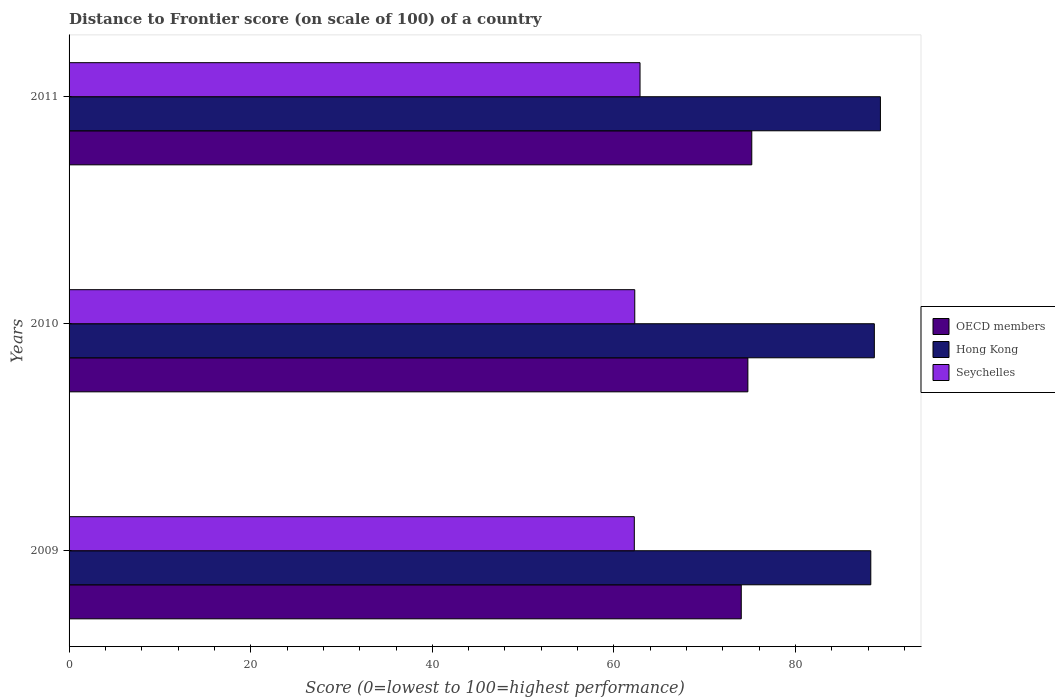How many different coloured bars are there?
Give a very brief answer. 3. How many bars are there on the 3rd tick from the top?
Give a very brief answer. 3. How many bars are there on the 2nd tick from the bottom?
Your answer should be compact. 3. What is the label of the 2nd group of bars from the top?
Give a very brief answer. 2010. In how many cases, is the number of bars for a given year not equal to the number of legend labels?
Give a very brief answer. 0. What is the distance to frontier score of in Seychelles in 2009?
Make the answer very short. 62.24. Across all years, what is the maximum distance to frontier score of in OECD members?
Make the answer very short. 75.18. Across all years, what is the minimum distance to frontier score of in Hong Kong?
Give a very brief answer. 88.28. In which year was the distance to frontier score of in OECD members minimum?
Your response must be concise. 2009. What is the total distance to frontier score of in OECD members in the graph?
Ensure brevity in your answer.  223.94. What is the difference between the distance to frontier score of in Seychelles in 2010 and that in 2011?
Provide a short and direct response. -0.58. What is the difference between the distance to frontier score of in OECD members in 2010 and the distance to frontier score of in Seychelles in 2011?
Offer a very short reply. 11.87. What is the average distance to frontier score of in Hong Kong per year?
Your answer should be compact. 88.76. In the year 2011, what is the difference between the distance to frontier score of in Hong Kong and distance to frontier score of in OECD members?
Give a very brief answer. 14.16. In how many years, is the distance to frontier score of in Seychelles greater than 4 ?
Your answer should be very brief. 3. What is the ratio of the distance to frontier score of in OECD members in 2009 to that in 2011?
Give a very brief answer. 0.98. What is the difference between the highest and the second highest distance to frontier score of in Hong Kong?
Keep it short and to the point. 0.67. What is the difference between the highest and the lowest distance to frontier score of in Seychelles?
Give a very brief answer. 0.63. What does the 1st bar from the top in 2009 represents?
Keep it short and to the point. Seychelles. How many bars are there?
Make the answer very short. 9. What is the difference between two consecutive major ticks on the X-axis?
Provide a succinct answer. 20. Where does the legend appear in the graph?
Your response must be concise. Center right. How are the legend labels stacked?
Your response must be concise. Vertical. What is the title of the graph?
Give a very brief answer. Distance to Frontier score (on scale of 100) of a country. What is the label or title of the X-axis?
Keep it short and to the point. Score (0=lowest to 100=highest performance). What is the Score (0=lowest to 100=highest performance) of OECD members in 2009?
Keep it short and to the point. 74.02. What is the Score (0=lowest to 100=highest performance) in Hong Kong in 2009?
Ensure brevity in your answer.  88.28. What is the Score (0=lowest to 100=highest performance) of Seychelles in 2009?
Make the answer very short. 62.24. What is the Score (0=lowest to 100=highest performance) of OECD members in 2010?
Your answer should be compact. 74.74. What is the Score (0=lowest to 100=highest performance) in Hong Kong in 2010?
Provide a succinct answer. 88.67. What is the Score (0=lowest to 100=highest performance) of Seychelles in 2010?
Keep it short and to the point. 62.29. What is the Score (0=lowest to 100=highest performance) of OECD members in 2011?
Provide a succinct answer. 75.18. What is the Score (0=lowest to 100=highest performance) of Hong Kong in 2011?
Offer a terse response. 89.34. What is the Score (0=lowest to 100=highest performance) in Seychelles in 2011?
Your response must be concise. 62.87. Across all years, what is the maximum Score (0=lowest to 100=highest performance) of OECD members?
Your answer should be very brief. 75.18. Across all years, what is the maximum Score (0=lowest to 100=highest performance) in Hong Kong?
Make the answer very short. 89.34. Across all years, what is the maximum Score (0=lowest to 100=highest performance) of Seychelles?
Your response must be concise. 62.87. Across all years, what is the minimum Score (0=lowest to 100=highest performance) in OECD members?
Make the answer very short. 74.02. Across all years, what is the minimum Score (0=lowest to 100=highest performance) of Hong Kong?
Provide a short and direct response. 88.28. Across all years, what is the minimum Score (0=lowest to 100=highest performance) of Seychelles?
Your answer should be compact. 62.24. What is the total Score (0=lowest to 100=highest performance) of OECD members in the graph?
Your answer should be compact. 223.94. What is the total Score (0=lowest to 100=highest performance) of Hong Kong in the graph?
Offer a very short reply. 266.29. What is the total Score (0=lowest to 100=highest performance) in Seychelles in the graph?
Your answer should be compact. 187.4. What is the difference between the Score (0=lowest to 100=highest performance) of OECD members in 2009 and that in 2010?
Offer a very short reply. -0.73. What is the difference between the Score (0=lowest to 100=highest performance) in Hong Kong in 2009 and that in 2010?
Make the answer very short. -0.39. What is the difference between the Score (0=lowest to 100=highest performance) in Seychelles in 2009 and that in 2010?
Your answer should be very brief. -0.05. What is the difference between the Score (0=lowest to 100=highest performance) of OECD members in 2009 and that in 2011?
Give a very brief answer. -1.16. What is the difference between the Score (0=lowest to 100=highest performance) in Hong Kong in 2009 and that in 2011?
Your answer should be very brief. -1.06. What is the difference between the Score (0=lowest to 100=highest performance) in Seychelles in 2009 and that in 2011?
Offer a terse response. -0.63. What is the difference between the Score (0=lowest to 100=highest performance) in OECD members in 2010 and that in 2011?
Your response must be concise. -0.43. What is the difference between the Score (0=lowest to 100=highest performance) in Hong Kong in 2010 and that in 2011?
Provide a short and direct response. -0.67. What is the difference between the Score (0=lowest to 100=highest performance) of Seychelles in 2010 and that in 2011?
Ensure brevity in your answer.  -0.58. What is the difference between the Score (0=lowest to 100=highest performance) in OECD members in 2009 and the Score (0=lowest to 100=highest performance) in Hong Kong in 2010?
Provide a short and direct response. -14.65. What is the difference between the Score (0=lowest to 100=highest performance) in OECD members in 2009 and the Score (0=lowest to 100=highest performance) in Seychelles in 2010?
Keep it short and to the point. 11.73. What is the difference between the Score (0=lowest to 100=highest performance) of Hong Kong in 2009 and the Score (0=lowest to 100=highest performance) of Seychelles in 2010?
Give a very brief answer. 25.99. What is the difference between the Score (0=lowest to 100=highest performance) of OECD members in 2009 and the Score (0=lowest to 100=highest performance) of Hong Kong in 2011?
Ensure brevity in your answer.  -15.32. What is the difference between the Score (0=lowest to 100=highest performance) in OECD members in 2009 and the Score (0=lowest to 100=highest performance) in Seychelles in 2011?
Provide a short and direct response. 11.15. What is the difference between the Score (0=lowest to 100=highest performance) of Hong Kong in 2009 and the Score (0=lowest to 100=highest performance) of Seychelles in 2011?
Offer a terse response. 25.41. What is the difference between the Score (0=lowest to 100=highest performance) in OECD members in 2010 and the Score (0=lowest to 100=highest performance) in Hong Kong in 2011?
Provide a short and direct response. -14.6. What is the difference between the Score (0=lowest to 100=highest performance) in OECD members in 2010 and the Score (0=lowest to 100=highest performance) in Seychelles in 2011?
Keep it short and to the point. 11.87. What is the difference between the Score (0=lowest to 100=highest performance) in Hong Kong in 2010 and the Score (0=lowest to 100=highest performance) in Seychelles in 2011?
Offer a very short reply. 25.8. What is the average Score (0=lowest to 100=highest performance) in OECD members per year?
Give a very brief answer. 74.65. What is the average Score (0=lowest to 100=highest performance) of Hong Kong per year?
Provide a short and direct response. 88.76. What is the average Score (0=lowest to 100=highest performance) of Seychelles per year?
Keep it short and to the point. 62.47. In the year 2009, what is the difference between the Score (0=lowest to 100=highest performance) in OECD members and Score (0=lowest to 100=highest performance) in Hong Kong?
Your response must be concise. -14.26. In the year 2009, what is the difference between the Score (0=lowest to 100=highest performance) of OECD members and Score (0=lowest to 100=highest performance) of Seychelles?
Offer a very short reply. 11.78. In the year 2009, what is the difference between the Score (0=lowest to 100=highest performance) of Hong Kong and Score (0=lowest to 100=highest performance) of Seychelles?
Offer a very short reply. 26.04. In the year 2010, what is the difference between the Score (0=lowest to 100=highest performance) in OECD members and Score (0=lowest to 100=highest performance) in Hong Kong?
Give a very brief answer. -13.93. In the year 2010, what is the difference between the Score (0=lowest to 100=highest performance) in OECD members and Score (0=lowest to 100=highest performance) in Seychelles?
Offer a terse response. 12.45. In the year 2010, what is the difference between the Score (0=lowest to 100=highest performance) of Hong Kong and Score (0=lowest to 100=highest performance) of Seychelles?
Provide a short and direct response. 26.38. In the year 2011, what is the difference between the Score (0=lowest to 100=highest performance) of OECD members and Score (0=lowest to 100=highest performance) of Hong Kong?
Make the answer very short. -14.16. In the year 2011, what is the difference between the Score (0=lowest to 100=highest performance) in OECD members and Score (0=lowest to 100=highest performance) in Seychelles?
Your answer should be very brief. 12.31. In the year 2011, what is the difference between the Score (0=lowest to 100=highest performance) in Hong Kong and Score (0=lowest to 100=highest performance) in Seychelles?
Make the answer very short. 26.47. What is the ratio of the Score (0=lowest to 100=highest performance) of OECD members in 2009 to that in 2010?
Your answer should be compact. 0.99. What is the ratio of the Score (0=lowest to 100=highest performance) in Hong Kong in 2009 to that in 2010?
Make the answer very short. 1. What is the ratio of the Score (0=lowest to 100=highest performance) of OECD members in 2009 to that in 2011?
Your answer should be very brief. 0.98. What is the ratio of the Score (0=lowest to 100=highest performance) of Hong Kong in 2009 to that in 2011?
Provide a short and direct response. 0.99. What is the ratio of the Score (0=lowest to 100=highest performance) in Hong Kong in 2010 to that in 2011?
Your answer should be very brief. 0.99. What is the ratio of the Score (0=lowest to 100=highest performance) of Seychelles in 2010 to that in 2011?
Provide a short and direct response. 0.99. What is the difference between the highest and the second highest Score (0=lowest to 100=highest performance) of OECD members?
Keep it short and to the point. 0.43. What is the difference between the highest and the second highest Score (0=lowest to 100=highest performance) in Hong Kong?
Keep it short and to the point. 0.67. What is the difference between the highest and the second highest Score (0=lowest to 100=highest performance) of Seychelles?
Your answer should be very brief. 0.58. What is the difference between the highest and the lowest Score (0=lowest to 100=highest performance) in OECD members?
Keep it short and to the point. 1.16. What is the difference between the highest and the lowest Score (0=lowest to 100=highest performance) in Hong Kong?
Give a very brief answer. 1.06. What is the difference between the highest and the lowest Score (0=lowest to 100=highest performance) of Seychelles?
Offer a terse response. 0.63. 